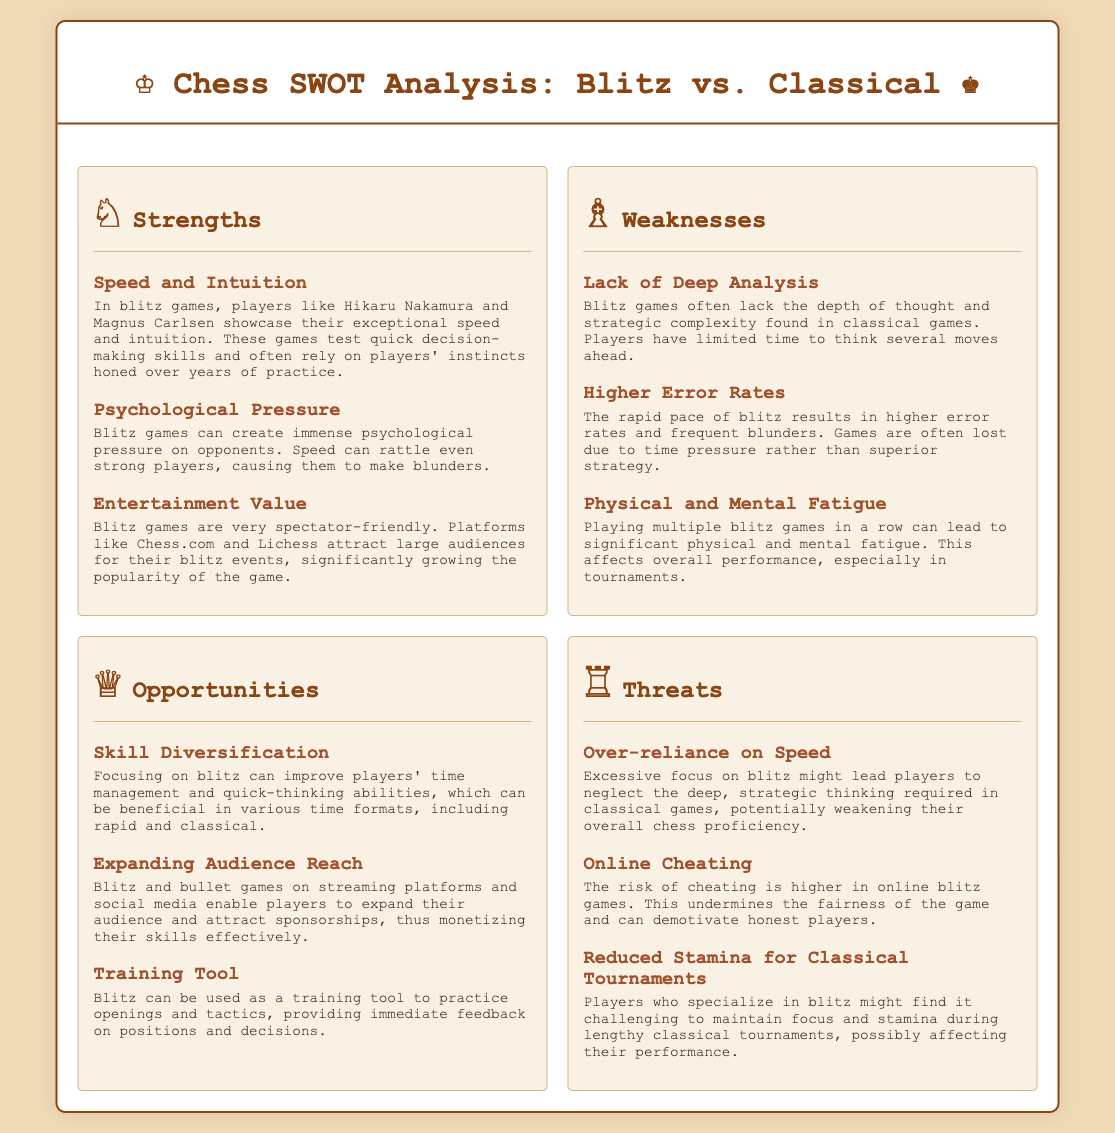what are the strengths of blitz games? The strengths section lists the advantages of blitz games such as speed and intuition, psychological pressure, and entertainment value.
Answer: Speed and intuition, psychological pressure, entertainment value what is a key weakness of blitz games? The weaknesses section outlines various drawbacks of blitz games, one of which is the lack of deep analysis.
Answer: Lack of deep analysis how does physical and mental fatigue affect blitz players? The weaknesses mention that physical and mental fatigue can significantly affect performance, especially during tournaments.
Answer: It affects overall performance how can blitz games be used as a training tool? The opportunities section states that blitz can be used to practice openings and tactics, providing immediate feedback on decisions.
Answer: As a training tool to practice openings and tactics what is one threat to players who focus on blitz? The threats section highlights several risks, including the over-reliance on speed, which can weaken overall proficiency in classical games.
Answer: Over-reliance on speed how many items are listed under strengths? The strengths section contains three specific items detailing various advantages of blitz games.
Answer: Three items which players are mentioned as examples of speed in blitz games? The strengths section references Hikaru Nakamura and Magnus Carlsen as examples of exceptional speed in blitz.
Answer: Hikaru Nakamura and Magnus Carlsen what type of games does the document analyze? The title of the document clearly indicates the focus is on comparing blitz and classical chess games.
Answer: Blitz vs. Classical how can blitz games impact stamina during classical tournaments? The threats note that players specializing in blitz might struggle to maintain stamina and focus during lengthy classical tournaments.
Answer: It may reduce stamina for classical tournaments 